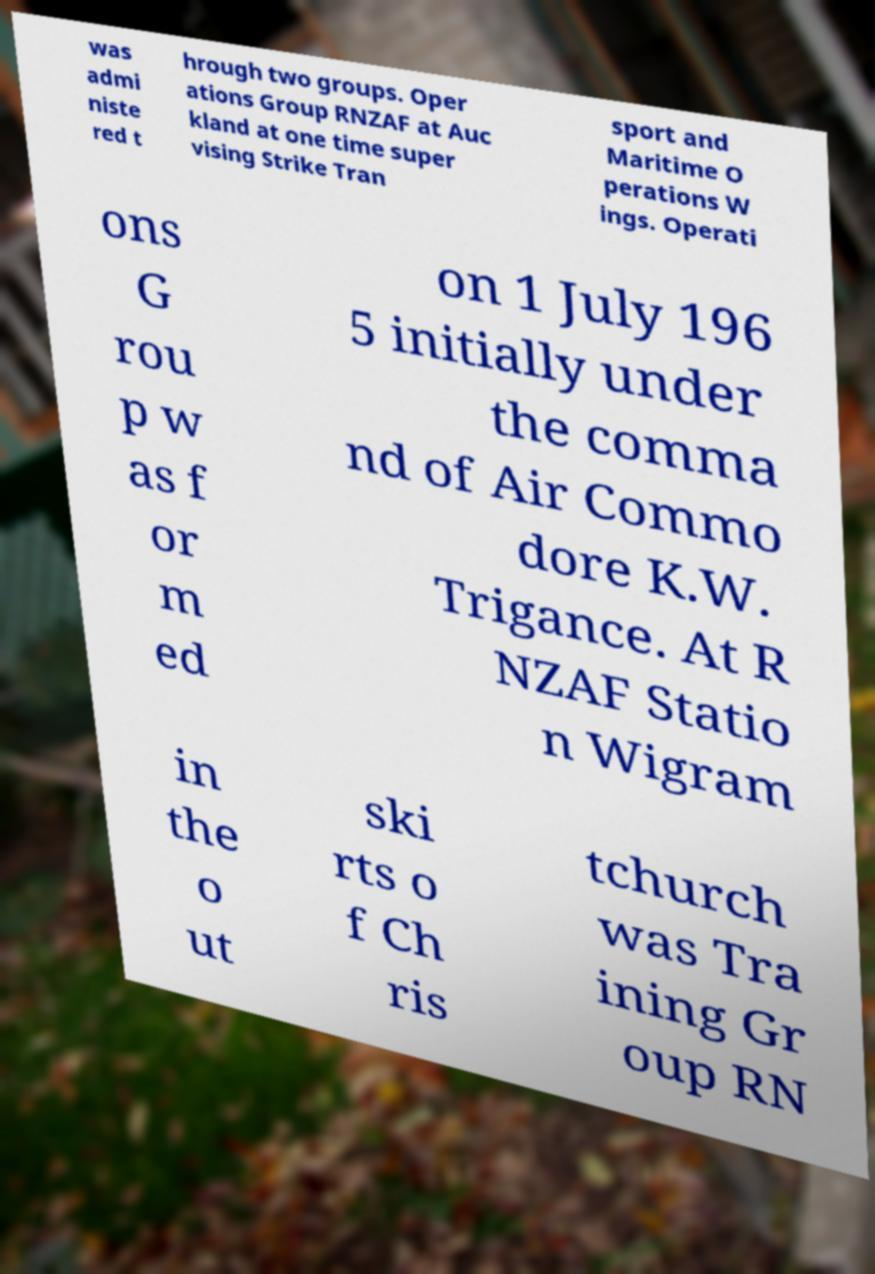Please identify and transcribe the text found in this image. was admi niste red t hrough two groups. Oper ations Group RNZAF at Auc kland at one time super vising Strike Tran sport and Maritime O perations W ings. Operati ons G rou p w as f or m ed on 1 July 196 5 initially under the comma nd of Air Commo dore K.W. Trigance. At R NZAF Statio n Wigram in the o ut ski rts o f Ch ris tchurch was Tra ining Gr oup RN 